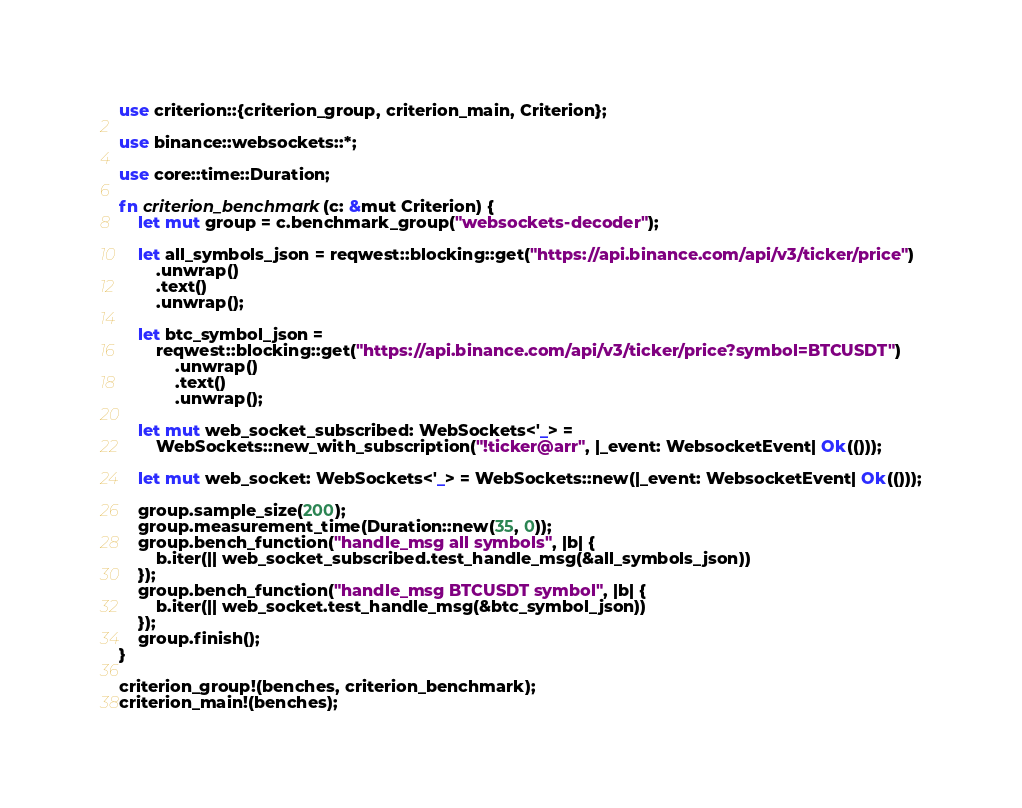Convert code to text. <code><loc_0><loc_0><loc_500><loc_500><_Rust_>use criterion::{criterion_group, criterion_main, Criterion};

use binance::websockets::*;

use core::time::Duration;

fn criterion_benchmark(c: &mut Criterion) {
    let mut group = c.benchmark_group("websockets-decoder");

    let all_symbols_json = reqwest::blocking::get("https://api.binance.com/api/v3/ticker/price")
        .unwrap()
        .text()
        .unwrap();

    let btc_symbol_json =
        reqwest::blocking::get("https://api.binance.com/api/v3/ticker/price?symbol=BTCUSDT")
            .unwrap()
            .text()
            .unwrap();

    let mut web_socket_subscribed: WebSockets<'_> =
        WebSockets::new_with_subscription("!ticker@arr", |_event: WebsocketEvent| Ok(()));

    let mut web_socket: WebSockets<'_> = WebSockets::new(|_event: WebsocketEvent| Ok(()));

    group.sample_size(200);
    group.measurement_time(Duration::new(35, 0));
    group.bench_function("handle_msg all symbols", |b| {
        b.iter(|| web_socket_subscribed.test_handle_msg(&all_symbols_json))
    });
    group.bench_function("handle_msg BTCUSDT symbol", |b| {
        b.iter(|| web_socket.test_handle_msg(&btc_symbol_json))
    });
    group.finish();
}

criterion_group!(benches, criterion_benchmark);
criterion_main!(benches);
</code> 